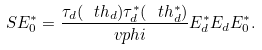Convert formula to latex. <formula><loc_0><loc_0><loc_500><loc_500>S E ^ { * } _ { 0 } = \frac { \tau _ { d } ( \ t h _ { d } ) \tau ^ { * } _ { d } ( \ t h ^ { * } _ { d } ) } { \ v p h i } E ^ { * } _ { d } E _ { d } E ^ { * } _ { 0 } .</formula> 